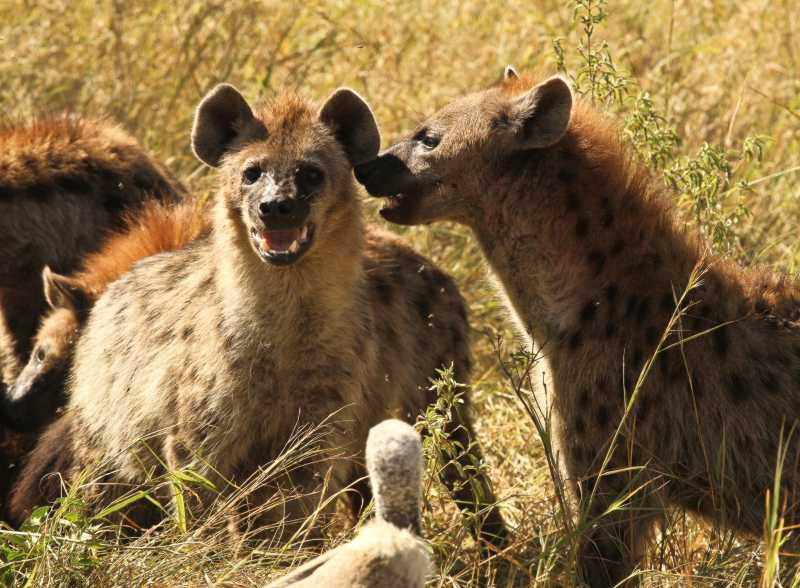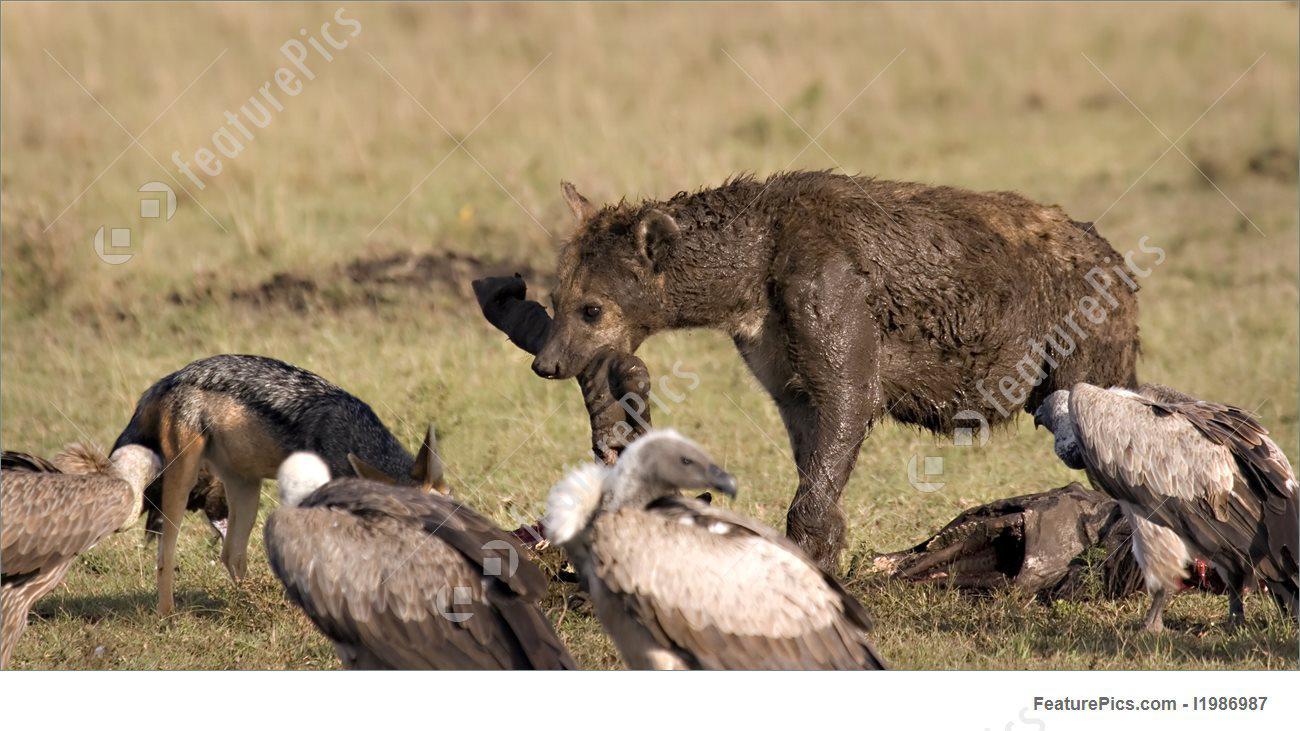The first image is the image on the left, the second image is the image on the right. Analyze the images presented: Is the assertion "IN at least one image there is an hyena facing left next to a small fox,vaulters and a dead animal." valid? Answer yes or no. Yes. 